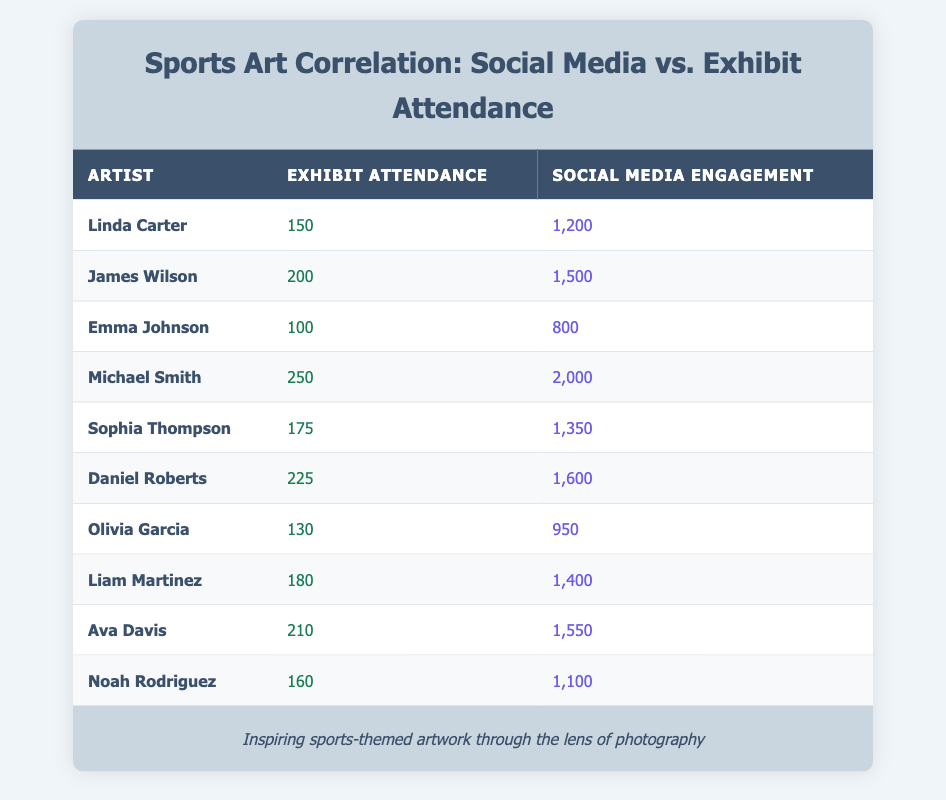What is the exhibit attendance of Michael Smith? Michael Smith is listed in the table under the artist column, and his exhibit attendance value is shown directly in the corresponding cell, which is 250.
Answer: 250 Who had the highest social media engagement? To find this, we compare the social media engagement values across all artists. Michael Smith has the highest engagement at 2000, as seen in his row.
Answer: 2000 What is the average exhibit attendance for all artists? There are 10 artists. Adding all their exhibit attendance values gives a total of 150 + 200 + 100 + 250 + 175 + 225 + 130 + 180 + 210 + 160 = 1880. Dividing 1880 by 10 gives an average of 188.
Answer: 188 Is Daniel Roberts's social media engagement higher than that of Olivia Garcia? Daniel Roberts has an engagement of 1600, while Olivia Garcia has 950. Since 1600 is greater than 950, the answer is yes.
Answer: Yes What is the difference between the social media engagement of Emma Johnson and Ava Davis? Emma Johnson's engagement is 800, and Ava Davis's is 1550. The difference is 1550 - 800 = 750.
Answer: 750 Which artist has the lowest exhibit attendance? By scanning the table for the lowest number under exhibit attendance, we see that Emma Johnson has 100, making her the artist with the lowest attendance.
Answer: Emma Johnson How many artists have social media engagement above 1400? Looking at the engagement values, we find the following artists with engagement above 1400: Michael Smith (2000), Daniel Roberts (1600), Ava Davis (1550), and Liam Martinez (1400). This makes a total of 4 artists.
Answer: 4 Is it true that both Linda Carter and Noah Rodriguez have more than 1200 social media engagements? Linda Carter has 1200, and Noah Rodriguez has 1100, which means only Linda meets the condition. Therefore, the statement is false.
Answer: No What is the total exhibit attendance for all artists combined? To find the total exhibit attendance, we add the attendance values: 150 + 200 + 100 + 250 + 175 + 225 + 130 + 180 + 210 + 160 = 1880.
Answer: 1880 